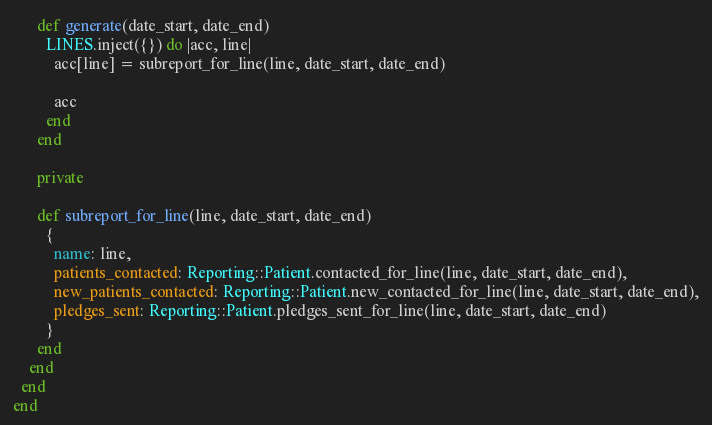Convert code to text. <code><loc_0><loc_0><loc_500><loc_500><_Ruby_>      def generate(date_start, date_end)
        LINES.inject({}) do |acc, line|
          acc[line] = subreport_for_line(line, date_start, date_end)

          acc
        end
      end

      private

      def subreport_for_line(line, date_start, date_end)
        {
          name: line,
          patients_contacted: Reporting::Patient.contacted_for_line(line, date_start, date_end),
          new_patients_contacted: Reporting::Patient.new_contacted_for_line(line, date_start, date_end),
          pledges_sent: Reporting::Patient.pledges_sent_for_line(line, date_start, date_end)
        }
      end
    end
  end
end
</code> 